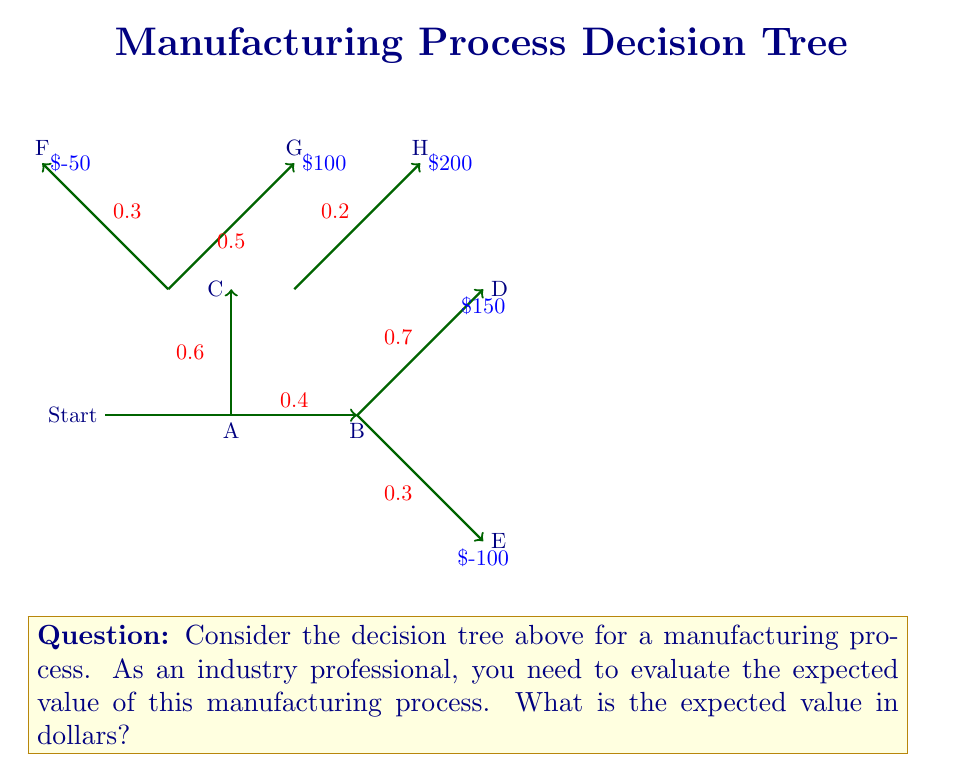Provide a solution to this math problem. To calculate the expected value, we need to work backwards from the leaf nodes, considering the probabilities and costs at each step.

Step 1: Evaluate node C
Expected value of C = (0.3 × -50) + (0.5 × 100) + (0.2 × 200)
                    = -15 + 50 + 40
                    = $75

Step 2: Evaluate node B
Expected value of B = (0.7 × 150) + (0.3 × -100)
                    = 105 - 30
                    = $75

Step 3: Evaluate node A (the root)
Expected value of A = (0.6 × 75) + (0.4 × 75)
                    = 45 + 30
                    = $75

Therefore, the expected value of the entire manufacturing process is $75.
Answer: $75 